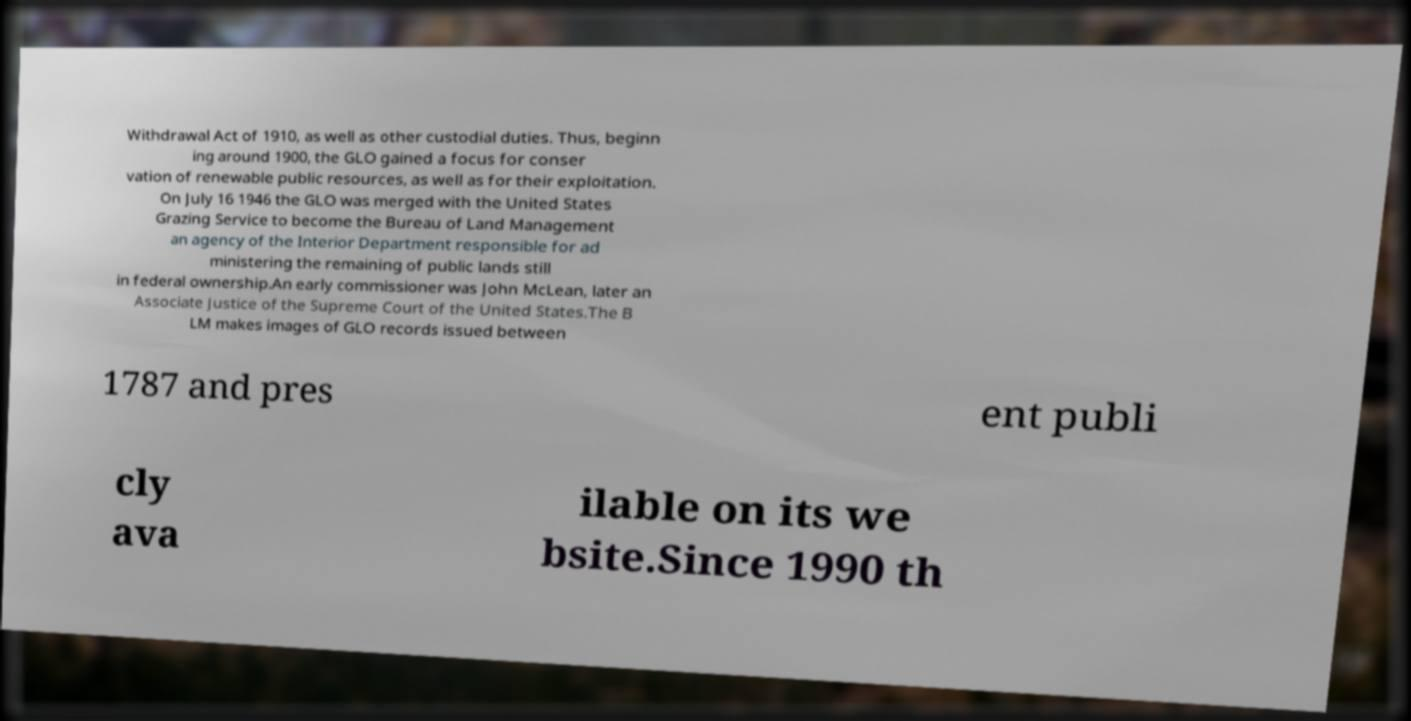What messages or text are displayed in this image? I need them in a readable, typed format. Withdrawal Act of 1910, as well as other custodial duties. Thus, beginn ing around 1900, the GLO gained a focus for conser vation of renewable public resources, as well as for their exploitation. On July 16 1946 the GLO was merged with the United States Grazing Service to become the Bureau of Land Management an agency of the Interior Department responsible for ad ministering the remaining of public lands still in federal ownership.An early commissioner was John McLean, later an Associate Justice of the Supreme Court of the United States.The B LM makes images of GLO records issued between 1787 and pres ent publi cly ava ilable on its we bsite.Since 1990 th 